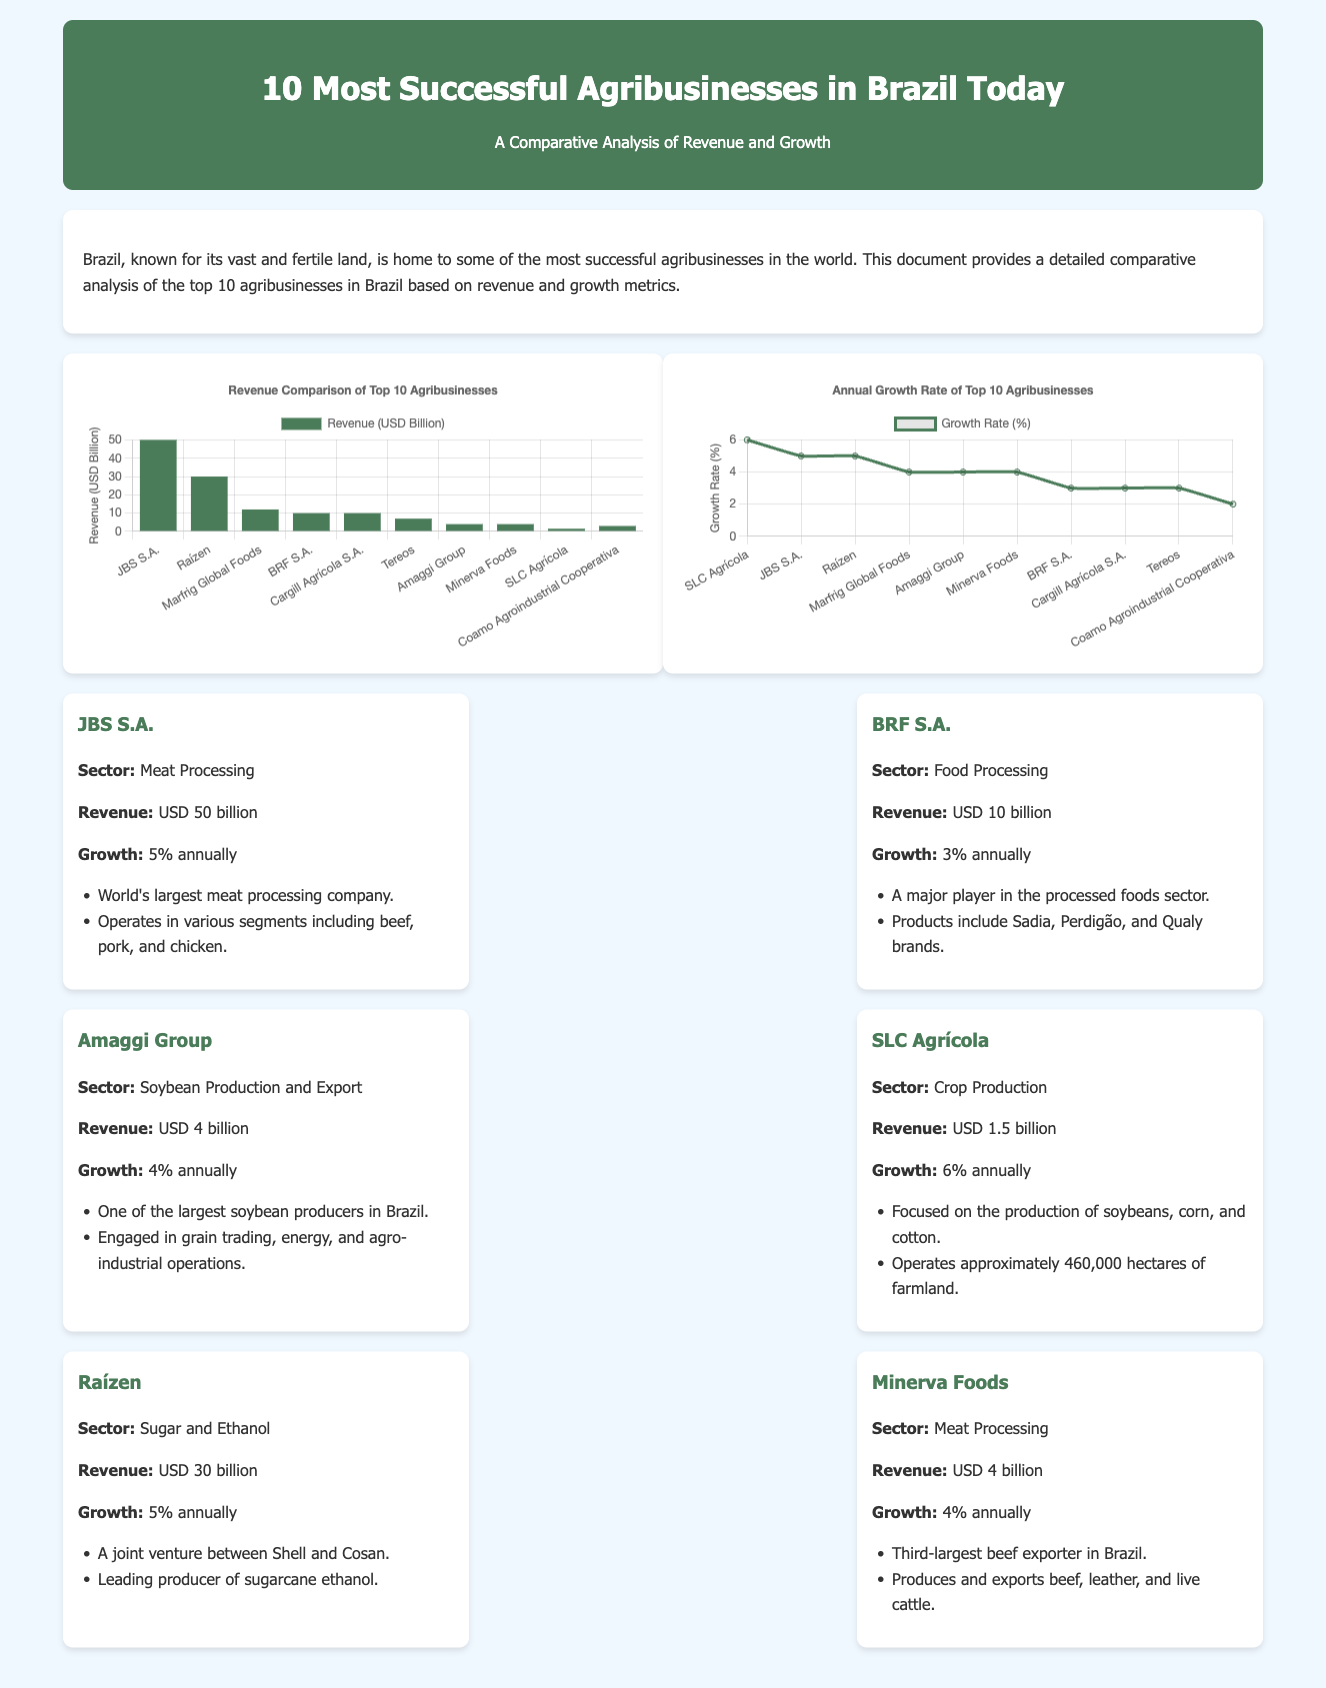What is the sector of JBS S.A.? The document lists the sectors for each company, and JBS S.A. is classified under Meat Processing.
Answer: Meat Processing What is the revenue of Raízen? According to the document, Raízen's revenue is stated as USD 30 billion.
Answer: USD 30 billion Which company has the highest growth rate? The chart shows that SLC Agrícola has the highest annual growth rate at 6%.
Answer: 6% What is the total revenue of the top 10 agribusinesses? By adding all specified revenues (50 + 30 + 12 + 10 + 10 + 7 + 4 + 4 + 1.5 + 3), the total revenue is given.
Answer: USD 137.5 billion Which company is the largest meat exporter in Brazil? The document mentions that Minerva Foods is the third-largest beef exporter, but does not specify the largest.
Answer: No answer (not explicitly stated) What is the growth rate of BRF S.A.? The growth rate for BRF S.A. is provided as 3% annually in the document.
Answer: 3% Which company operates in the soybean production sector? The document states that the Amaggi Group operates in soybean production and export.
Answer: Amaggi Group What type of chart is used to show the revenue comparison? The infographic uses a bar chart to display revenue comparison among agribusinesses.
Answer: Bar chart 